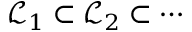<formula> <loc_0><loc_0><loc_500><loc_500>{ \mathcal { L } } _ { 1 } \subset { \mathcal { L } } _ { 2 } \subset \cdots</formula> 